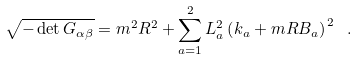Convert formula to latex. <formula><loc_0><loc_0><loc_500><loc_500>\sqrt { - \det G _ { \alpha \beta } } = m ^ { 2 } R ^ { 2 } + \sum _ { a = 1 } ^ { 2 } L _ { a } ^ { 2 } \left ( k _ { a } + m R B _ { a } \right ) ^ { \, 2 } \ .</formula> 